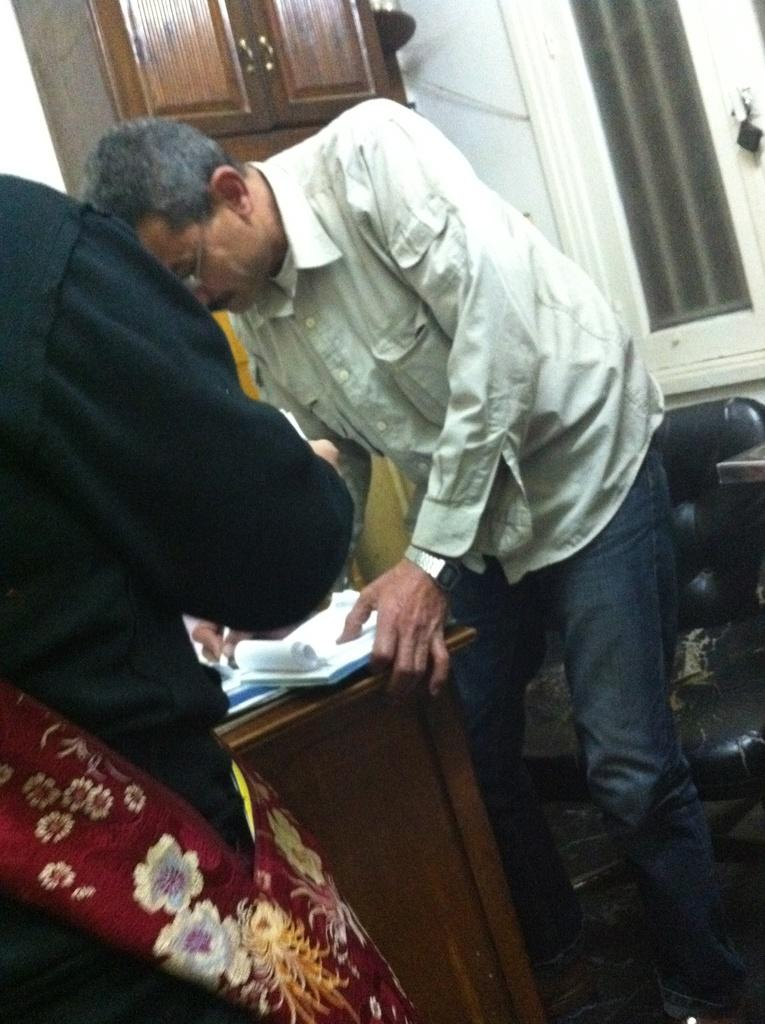What is the man in the white shirt doing in the image? The man in the white shirt is signing a paper in the image. How is the man in the white shirt positioned in relation to the table? The man in the white shirt is leaning on a table in the image. Can you describe the other man in the image? There is a man in a black shirt in the image, and he is standing on the left side. What can be seen on the wall in the background? There are doors on the wall in the background of the image. What type of bait is the man in the black shirt using to catch fish in the image? There is no mention of fishing or bait in the image; it features two men and a table with a paper. How many pages are visible in the image? The image does not show any pages, only a man signing a paper. 